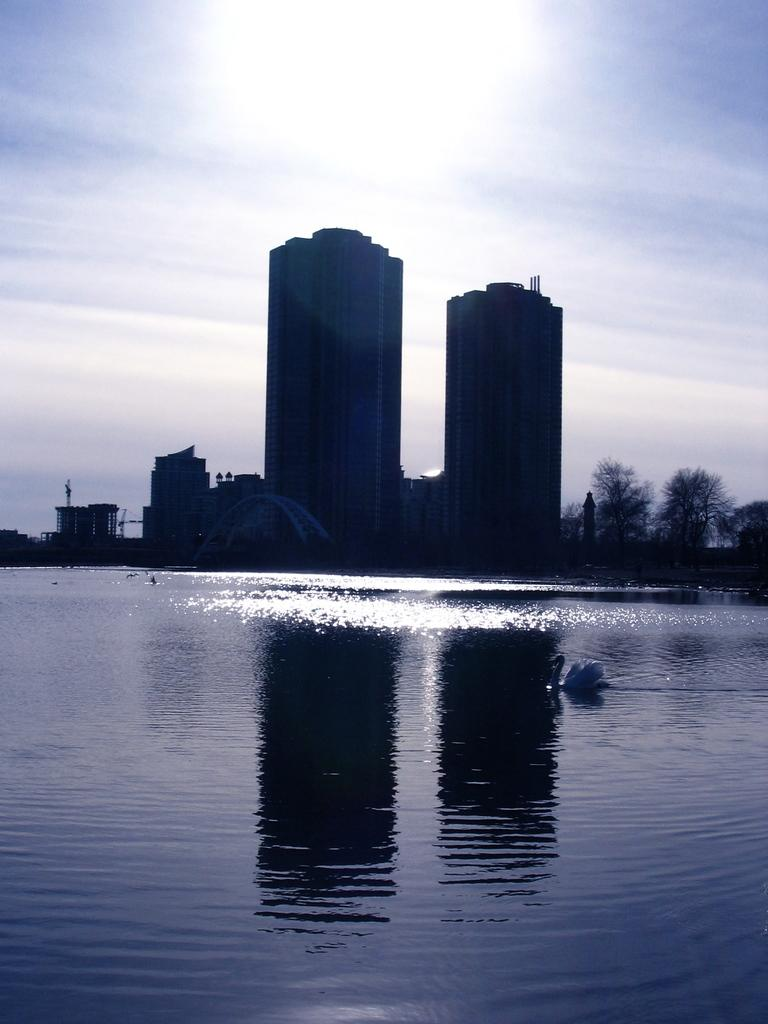What type of structure is present in the image? There is a building in the image. What can be seen near the building? There is a grill and water visible in the image. What type of animal is in the image? There is a swan in the image. What type of vegetation is present in the image? There are trees in the image. What part of the natural environment is visible in the image? The sky is visible in the image, and it has clouds. What type of fuel is being used by the committee in the image? There is no committee or fuel present in the image. How many baseballs can be seen in the image? There are no baseballs present in the image. 